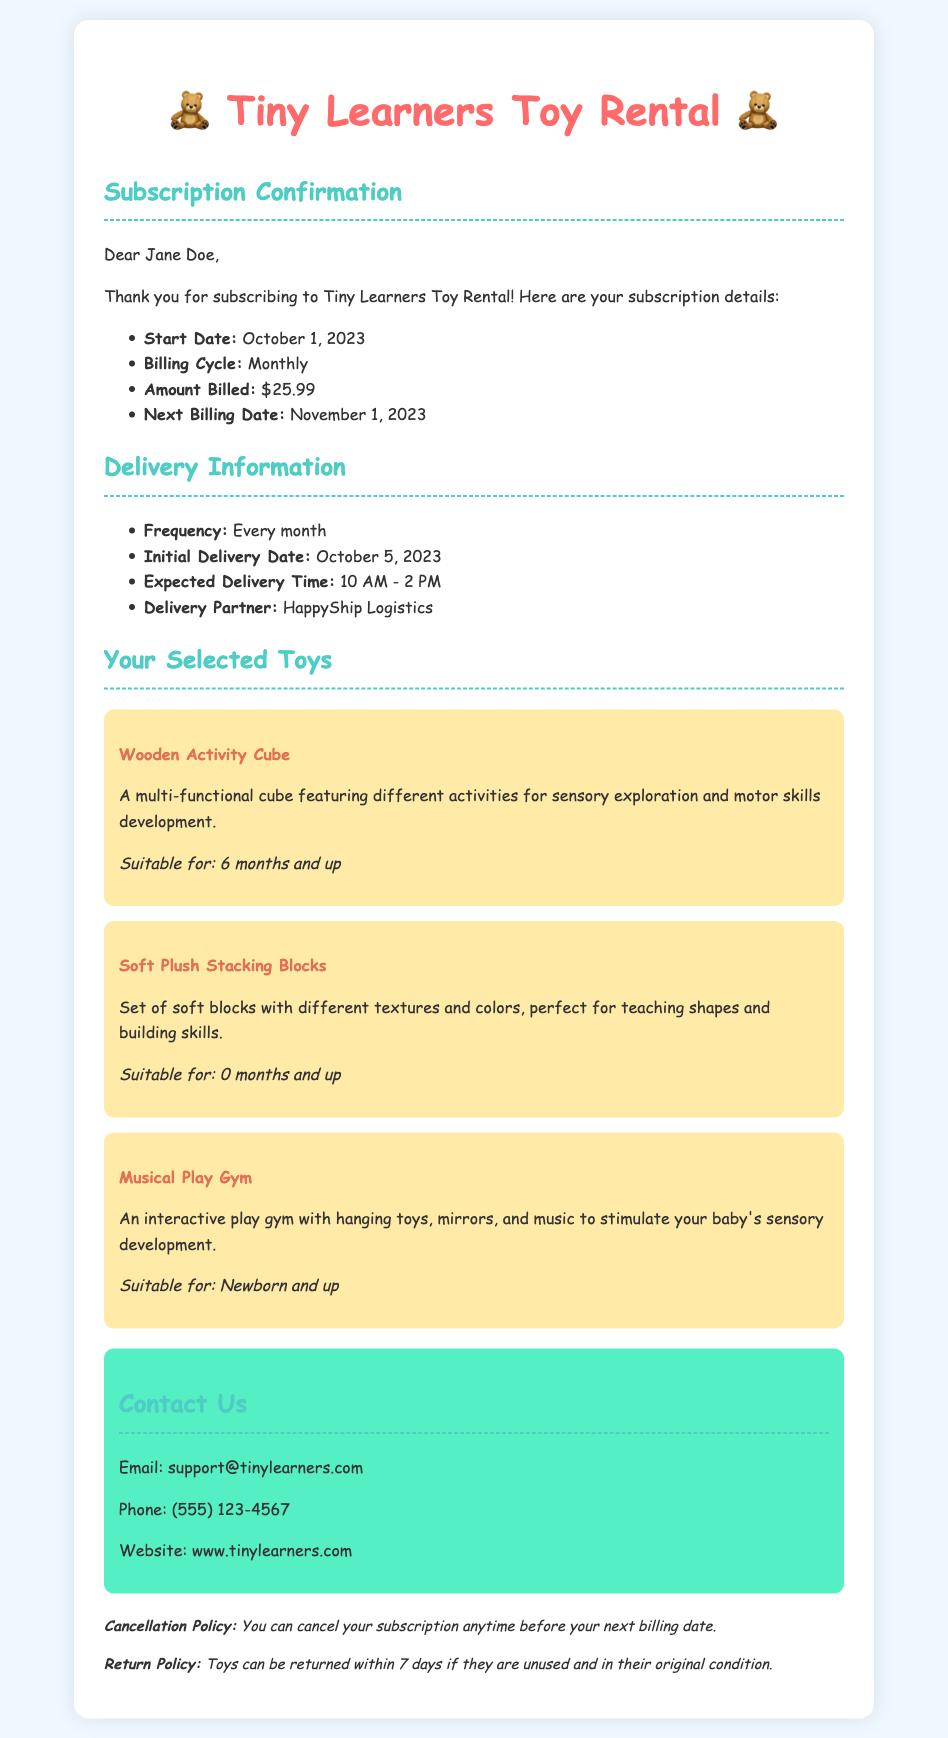What is the subscriber's name? The subscriber's name is mentioned in the introduction of the document.
Answer: Jane Doe What is the start date of the subscription? The start date of the subscription is listed in the subscription details section.
Answer: October 1, 2023 What is the amount billed per month? The monthly billing amount is specified in the subscription details.
Answer: $25.99 What is the initial delivery date? The initial delivery date is provided in the delivery information section.
Answer: October 5, 2023 What toys are included in the subscription? The document lists the specific toys selected for rental under the "Your Selected Toys" section.
Answer: Wooden Activity Cube, Soft Plush Stacking Blocks, Musical Play Gym What age is the Musical Play Gym suitable for? The suitable age for the Musical Play Gym is indicated under its description.
Answer: Newborn and up Who is the delivery partner? The document specifies the delivery partner in the delivery information section.
Answer: HappyShip Logistics What is the cancellation policy? The cancellation policy is stated towards the end of the document.
Answer: You can cancel your subscription anytime before your next billing date What are the contact details for support? The contact details for support are provided in a dedicated section.
Answer: Email: support@tinylearners.com, Phone: (555) 123-4567, Website: www.tinylearners.com 